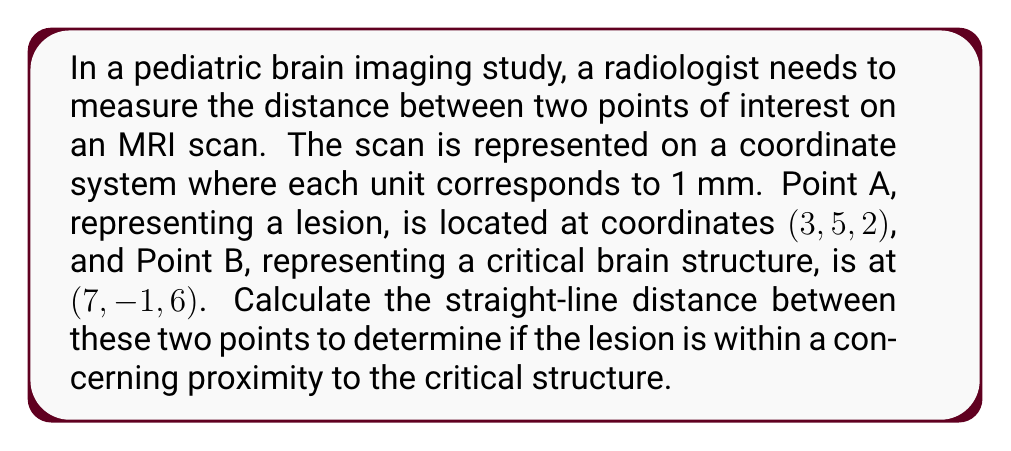What is the answer to this math problem? To solve this problem, we'll use the three-dimensional distance formula, which is an extension of the Pythagorean theorem to 3D space.

1) The distance formula in 3D space is:
   $$d = \sqrt{(x_2-x_1)^2 + (y_2-y_1)^2 + (z_2-z_1)^2}$$

2) We have:
   Point A (lesion): $(x_1, y_1, z_1) = (3, 5, 2)$
   Point B (critical structure): $(x_2, y_2, z_2) = (7, -1, 6)$

3) Let's substitute these values into the formula:
   $$d = \sqrt{(7-3)^2 + (-1-5)^2 + (6-2)^2}$$

4) Simplify the expressions inside the parentheses:
   $$d = \sqrt{4^2 + (-6)^2 + 4^2}$$

5) Calculate the squares:
   $$d = \sqrt{16 + 36 + 16}$$

6) Add the terms under the square root:
   $$d = \sqrt{68}$$

7) Simplify the square root:
   $$d = 2\sqrt{17}$$

8) This result is in the units of the coordinate system, which we established as millimeters (mm).
Answer: The distance between the lesion and the critical brain structure is $2\sqrt{17}$ mm (approximately 8.25 mm). 